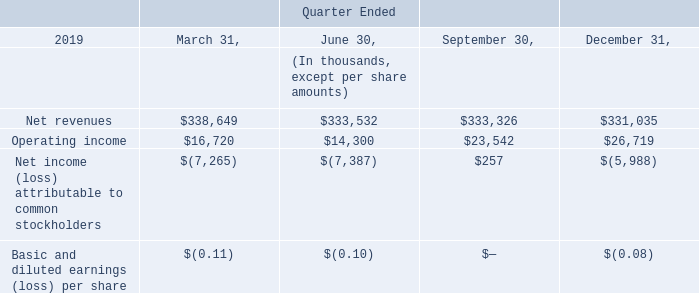15. QUARTERLY FINANCIAL INFORMATION (UNAUDITED)
During the quarter ended December 31, 2019, we purchased a group annuity contract to transfer the pension benefit obligations and annuity administration for a select group of retirees or their beneficiaries to an annuity provider. As a result of the transfer of the pension liability to the annuity provider and other lump sum payments to participants of the Pension Plans, we recognized a non-cash pension settlement charge of $6.7 million during the quarter ended December 31, 2019.
In 2019, we recognized a gain on extinguishment of debt from the partial repurchase of our Senior Notes of $0.3 million, $1.1 million and $3.1 million during the quarters ended June 30, 2019, September 30, 2019, and December 31, 2019, respectively.
As part of our integration efforts of FairPoint and continued cost saving initiatives, we incurred severance costs of $8.7 million during the quarter ended December 31, 2019.
What was the non-cash pension settlement charge recognized in the quarter ended 31 December 2019? $6.7 million. What was the gain on extinguishment of debt recognized in June 2019? $0.3 million. What was the gain on extinguishment of debt recognized in December 2019? $3.1 million. What was the increase / (decrease) in the net revenues from March 31, 2019 to December 31 2019?
Answer scale should be: thousand. 331,035 - 338,649
Answer: -7614. What is the average Operating income for each quarter in 2019?
Answer scale should be: thousand. (16,720 + 14,300 + 23,542 + 26,719) / 4
Answer: 20320.25. What was the total percentage increase / (decrease) in the Net income (loss) attributable to common stockholders from March 2019 to December 2019?
Answer scale should be: percent. -5,988 / -7,265 - 1
Answer: -17.58. 